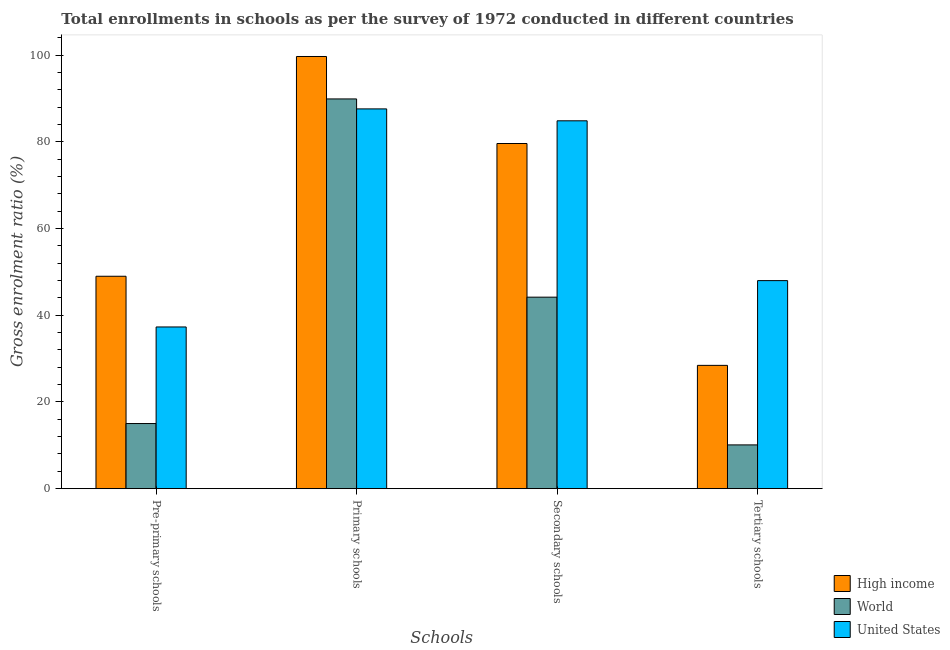How many different coloured bars are there?
Offer a very short reply. 3. How many groups of bars are there?
Your answer should be very brief. 4. Are the number of bars per tick equal to the number of legend labels?
Ensure brevity in your answer.  Yes. What is the label of the 2nd group of bars from the left?
Your answer should be very brief. Primary schools. What is the gross enrolment ratio in primary schools in United States?
Keep it short and to the point. 87.58. Across all countries, what is the maximum gross enrolment ratio in secondary schools?
Offer a very short reply. 84.83. Across all countries, what is the minimum gross enrolment ratio in pre-primary schools?
Ensure brevity in your answer.  15.02. In which country was the gross enrolment ratio in primary schools minimum?
Your answer should be very brief. United States. What is the total gross enrolment ratio in secondary schools in the graph?
Your response must be concise. 208.6. What is the difference between the gross enrolment ratio in tertiary schools in World and that in United States?
Provide a short and direct response. -37.88. What is the difference between the gross enrolment ratio in tertiary schools in High income and the gross enrolment ratio in primary schools in World?
Keep it short and to the point. -61.44. What is the average gross enrolment ratio in secondary schools per country?
Your answer should be compact. 69.53. What is the difference between the gross enrolment ratio in tertiary schools and gross enrolment ratio in primary schools in High income?
Ensure brevity in your answer.  -71.23. In how many countries, is the gross enrolment ratio in pre-primary schools greater than 44 %?
Ensure brevity in your answer.  1. What is the ratio of the gross enrolment ratio in primary schools in High income to that in World?
Ensure brevity in your answer.  1.11. Is the difference between the gross enrolment ratio in secondary schools in World and United States greater than the difference between the gross enrolment ratio in pre-primary schools in World and United States?
Provide a succinct answer. No. What is the difference between the highest and the second highest gross enrolment ratio in secondary schools?
Provide a succinct answer. 5.23. What is the difference between the highest and the lowest gross enrolment ratio in primary schools?
Keep it short and to the point. 12.09. What does the 2nd bar from the left in Tertiary schools represents?
Keep it short and to the point. World. How many countries are there in the graph?
Offer a terse response. 3. Are the values on the major ticks of Y-axis written in scientific E-notation?
Offer a very short reply. No. Does the graph contain grids?
Provide a short and direct response. No. Where does the legend appear in the graph?
Provide a short and direct response. Bottom right. How many legend labels are there?
Offer a terse response. 3. How are the legend labels stacked?
Provide a short and direct response. Vertical. What is the title of the graph?
Make the answer very short. Total enrollments in schools as per the survey of 1972 conducted in different countries. Does "Mexico" appear as one of the legend labels in the graph?
Your answer should be very brief. No. What is the label or title of the X-axis?
Make the answer very short. Schools. What is the label or title of the Y-axis?
Make the answer very short. Gross enrolment ratio (%). What is the Gross enrolment ratio (%) of High income in Pre-primary schools?
Make the answer very short. 48.99. What is the Gross enrolment ratio (%) in World in Pre-primary schools?
Ensure brevity in your answer.  15.02. What is the Gross enrolment ratio (%) in United States in Pre-primary schools?
Keep it short and to the point. 37.29. What is the Gross enrolment ratio (%) in High income in Primary schools?
Ensure brevity in your answer.  99.67. What is the Gross enrolment ratio (%) of World in Primary schools?
Ensure brevity in your answer.  89.88. What is the Gross enrolment ratio (%) in United States in Primary schools?
Your response must be concise. 87.58. What is the Gross enrolment ratio (%) in High income in Secondary schools?
Offer a very short reply. 79.6. What is the Gross enrolment ratio (%) of World in Secondary schools?
Ensure brevity in your answer.  44.16. What is the Gross enrolment ratio (%) in United States in Secondary schools?
Give a very brief answer. 84.83. What is the Gross enrolment ratio (%) of High income in Tertiary schools?
Make the answer very short. 28.44. What is the Gross enrolment ratio (%) in World in Tertiary schools?
Your answer should be compact. 10.09. What is the Gross enrolment ratio (%) of United States in Tertiary schools?
Keep it short and to the point. 47.98. Across all Schools, what is the maximum Gross enrolment ratio (%) in High income?
Keep it short and to the point. 99.67. Across all Schools, what is the maximum Gross enrolment ratio (%) of World?
Your answer should be very brief. 89.88. Across all Schools, what is the maximum Gross enrolment ratio (%) in United States?
Ensure brevity in your answer.  87.58. Across all Schools, what is the minimum Gross enrolment ratio (%) in High income?
Offer a terse response. 28.44. Across all Schools, what is the minimum Gross enrolment ratio (%) in World?
Provide a succinct answer. 10.09. Across all Schools, what is the minimum Gross enrolment ratio (%) in United States?
Provide a succinct answer. 37.29. What is the total Gross enrolment ratio (%) in High income in the graph?
Offer a terse response. 256.69. What is the total Gross enrolment ratio (%) of World in the graph?
Provide a short and direct response. 159.16. What is the total Gross enrolment ratio (%) of United States in the graph?
Give a very brief answer. 257.69. What is the difference between the Gross enrolment ratio (%) of High income in Pre-primary schools and that in Primary schools?
Offer a very short reply. -50.68. What is the difference between the Gross enrolment ratio (%) of World in Pre-primary schools and that in Primary schools?
Give a very brief answer. -74.86. What is the difference between the Gross enrolment ratio (%) of United States in Pre-primary schools and that in Primary schools?
Keep it short and to the point. -50.29. What is the difference between the Gross enrolment ratio (%) of High income in Pre-primary schools and that in Secondary schools?
Offer a terse response. -30.61. What is the difference between the Gross enrolment ratio (%) in World in Pre-primary schools and that in Secondary schools?
Offer a terse response. -29.14. What is the difference between the Gross enrolment ratio (%) in United States in Pre-primary schools and that in Secondary schools?
Provide a short and direct response. -47.54. What is the difference between the Gross enrolment ratio (%) in High income in Pre-primary schools and that in Tertiary schools?
Make the answer very short. 20.55. What is the difference between the Gross enrolment ratio (%) of World in Pre-primary schools and that in Tertiary schools?
Ensure brevity in your answer.  4.93. What is the difference between the Gross enrolment ratio (%) in United States in Pre-primary schools and that in Tertiary schools?
Your answer should be compact. -10.69. What is the difference between the Gross enrolment ratio (%) in High income in Primary schools and that in Secondary schools?
Ensure brevity in your answer.  20.07. What is the difference between the Gross enrolment ratio (%) of World in Primary schools and that in Secondary schools?
Give a very brief answer. 45.72. What is the difference between the Gross enrolment ratio (%) of United States in Primary schools and that in Secondary schools?
Provide a short and direct response. 2.75. What is the difference between the Gross enrolment ratio (%) of High income in Primary schools and that in Tertiary schools?
Ensure brevity in your answer.  71.23. What is the difference between the Gross enrolment ratio (%) of World in Primary schools and that in Tertiary schools?
Provide a short and direct response. 79.79. What is the difference between the Gross enrolment ratio (%) of United States in Primary schools and that in Tertiary schools?
Your answer should be compact. 39.6. What is the difference between the Gross enrolment ratio (%) of High income in Secondary schools and that in Tertiary schools?
Make the answer very short. 51.16. What is the difference between the Gross enrolment ratio (%) of World in Secondary schools and that in Tertiary schools?
Provide a succinct answer. 34.07. What is the difference between the Gross enrolment ratio (%) of United States in Secondary schools and that in Tertiary schools?
Your answer should be compact. 36.85. What is the difference between the Gross enrolment ratio (%) in High income in Pre-primary schools and the Gross enrolment ratio (%) in World in Primary schools?
Provide a succinct answer. -40.89. What is the difference between the Gross enrolment ratio (%) in High income in Pre-primary schools and the Gross enrolment ratio (%) in United States in Primary schools?
Offer a very short reply. -38.6. What is the difference between the Gross enrolment ratio (%) in World in Pre-primary schools and the Gross enrolment ratio (%) in United States in Primary schools?
Make the answer very short. -72.56. What is the difference between the Gross enrolment ratio (%) of High income in Pre-primary schools and the Gross enrolment ratio (%) of World in Secondary schools?
Offer a very short reply. 4.82. What is the difference between the Gross enrolment ratio (%) of High income in Pre-primary schools and the Gross enrolment ratio (%) of United States in Secondary schools?
Make the answer very short. -35.85. What is the difference between the Gross enrolment ratio (%) in World in Pre-primary schools and the Gross enrolment ratio (%) in United States in Secondary schools?
Offer a terse response. -69.81. What is the difference between the Gross enrolment ratio (%) in High income in Pre-primary schools and the Gross enrolment ratio (%) in World in Tertiary schools?
Provide a succinct answer. 38.89. What is the difference between the Gross enrolment ratio (%) of High income in Pre-primary schools and the Gross enrolment ratio (%) of United States in Tertiary schools?
Offer a very short reply. 1.01. What is the difference between the Gross enrolment ratio (%) of World in Pre-primary schools and the Gross enrolment ratio (%) of United States in Tertiary schools?
Give a very brief answer. -32.96. What is the difference between the Gross enrolment ratio (%) of High income in Primary schools and the Gross enrolment ratio (%) of World in Secondary schools?
Provide a succinct answer. 55.5. What is the difference between the Gross enrolment ratio (%) in High income in Primary schools and the Gross enrolment ratio (%) in United States in Secondary schools?
Provide a short and direct response. 14.83. What is the difference between the Gross enrolment ratio (%) in World in Primary schools and the Gross enrolment ratio (%) in United States in Secondary schools?
Offer a terse response. 5.05. What is the difference between the Gross enrolment ratio (%) in High income in Primary schools and the Gross enrolment ratio (%) in World in Tertiary schools?
Offer a very short reply. 89.57. What is the difference between the Gross enrolment ratio (%) of High income in Primary schools and the Gross enrolment ratio (%) of United States in Tertiary schools?
Give a very brief answer. 51.69. What is the difference between the Gross enrolment ratio (%) in World in Primary schools and the Gross enrolment ratio (%) in United States in Tertiary schools?
Give a very brief answer. 41.9. What is the difference between the Gross enrolment ratio (%) in High income in Secondary schools and the Gross enrolment ratio (%) in World in Tertiary schools?
Make the answer very short. 69.5. What is the difference between the Gross enrolment ratio (%) in High income in Secondary schools and the Gross enrolment ratio (%) in United States in Tertiary schools?
Your response must be concise. 31.62. What is the difference between the Gross enrolment ratio (%) in World in Secondary schools and the Gross enrolment ratio (%) in United States in Tertiary schools?
Keep it short and to the point. -3.81. What is the average Gross enrolment ratio (%) in High income per Schools?
Offer a terse response. 64.17. What is the average Gross enrolment ratio (%) in World per Schools?
Provide a short and direct response. 39.79. What is the average Gross enrolment ratio (%) of United States per Schools?
Your answer should be compact. 64.42. What is the difference between the Gross enrolment ratio (%) in High income and Gross enrolment ratio (%) in World in Pre-primary schools?
Ensure brevity in your answer.  33.97. What is the difference between the Gross enrolment ratio (%) in High income and Gross enrolment ratio (%) in United States in Pre-primary schools?
Offer a very short reply. 11.69. What is the difference between the Gross enrolment ratio (%) in World and Gross enrolment ratio (%) in United States in Pre-primary schools?
Provide a succinct answer. -22.27. What is the difference between the Gross enrolment ratio (%) of High income and Gross enrolment ratio (%) of World in Primary schools?
Give a very brief answer. 9.79. What is the difference between the Gross enrolment ratio (%) in High income and Gross enrolment ratio (%) in United States in Primary schools?
Provide a short and direct response. 12.09. What is the difference between the Gross enrolment ratio (%) of World and Gross enrolment ratio (%) of United States in Primary schools?
Offer a very short reply. 2.3. What is the difference between the Gross enrolment ratio (%) in High income and Gross enrolment ratio (%) in World in Secondary schools?
Your answer should be compact. 35.43. What is the difference between the Gross enrolment ratio (%) of High income and Gross enrolment ratio (%) of United States in Secondary schools?
Provide a succinct answer. -5.23. What is the difference between the Gross enrolment ratio (%) in World and Gross enrolment ratio (%) in United States in Secondary schools?
Your answer should be compact. -40.67. What is the difference between the Gross enrolment ratio (%) of High income and Gross enrolment ratio (%) of World in Tertiary schools?
Provide a short and direct response. 18.34. What is the difference between the Gross enrolment ratio (%) of High income and Gross enrolment ratio (%) of United States in Tertiary schools?
Offer a terse response. -19.54. What is the difference between the Gross enrolment ratio (%) in World and Gross enrolment ratio (%) in United States in Tertiary schools?
Ensure brevity in your answer.  -37.88. What is the ratio of the Gross enrolment ratio (%) in High income in Pre-primary schools to that in Primary schools?
Provide a short and direct response. 0.49. What is the ratio of the Gross enrolment ratio (%) of World in Pre-primary schools to that in Primary schools?
Your answer should be very brief. 0.17. What is the ratio of the Gross enrolment ratio (%) in United States in Pre-primary schools to that in Primary schools?
Keep it short and to the point. 0.43. What is the ratio of the Gross enrolment ratio (%) of High income in Pre-primary schools to that in Secondary schools?
Ensure brevity in your answer.  0.62. What is the ratio of the Gross enrolment ratio (%) of World in Pre-primary schools to that in Secondary schools?
Your response must be concise. 0.34. What is the ratio of the Gross enrolment ratio (%) of United States in Pre-primary schools to that in Secondary schools?
Offer a very short reply. 0.44. What is the ratio of the Gross enrolment ratio (%) of High income in Pre-primary schools to that in Tertiary schools?
Offer a very short reply. 1.72. What is the ratio of the Gross enrolment ratio (%) in World in Pre-primary schools to that in Tertiary schools?
Offer a terse response. 1.49. What is the ratio of the Gross enrolment ratio (%) of United States in Pre-primary schools to that in Tertiary schools?
Keep it short and to the point. 0.78. What is the ratio of the Gross enrolment ratio (%) of High income in Primary schools to that in Secondary schools?
Give a very brief answer. 1.25. What is the ratio of the Gross enrolment ratio (%) of World in Primary schools to that in Secondary schools?
Offer a terse response. 2.04. What is the ratio of the Gross enrolment ratio (%) of United States in Primary schools to that in Secondary schools?
Ensure brevity in your answer.  1.03. What is the ratio of the Gross enrolment ratio (%) in High income in Primary schools to that in Tertiary schools?
Ensure brevity in your answer.  3.5. What is the ratio of the Gross enrolment ratio (%) in World in Primary schools to that in Tertiary schools?
Provide a short and direct response. 8.9. What is the ratio of the Gross enrolment ratio (%) in United States in Primary schools to that in Tertiary schools?
Ensure brevity in your answer.  1.83. What is the ratio of the Gross enrolment ratio (%) of High income in Secondary schools to that in Tertiary schools?
Make the answer very short. 2.8. What is the ratio of the Gross enrolment ratio (%) in World in Secondary schools to that in Tertiary schools?
Offer a very short reply. 4.38. What is the ratio of the Gross enrolment ratio (%) of United States in Secondary schools to that in Tertiary schools?
Give a very brief answer. 1.77. What is the difference between the highest and the second highest Gross enrolment ratio (%) of High income?
Your answer should be very brief. 20.07. What is the difference between the highest and the second highest Gross enrolment ratio (%) of World?
Keep it short and to the point. 45.72. What is the difference between the highest and the second highest Gross enrolment ratio (%) of United States?
Your answer should be very brief. 2.75. What is the difference between the highest and the lowest Gross enrolment ratio (%) of High income?
Offer a terse response. 71.23. What is the difference between the highest and the lowest Gross enrolment ratio (%) of World?
Your response must be concise. 79.79. What is the difference between the highest and the lowest Gross enrolment ratio (%) of United States?
Your answer should be compact. 50.29. 